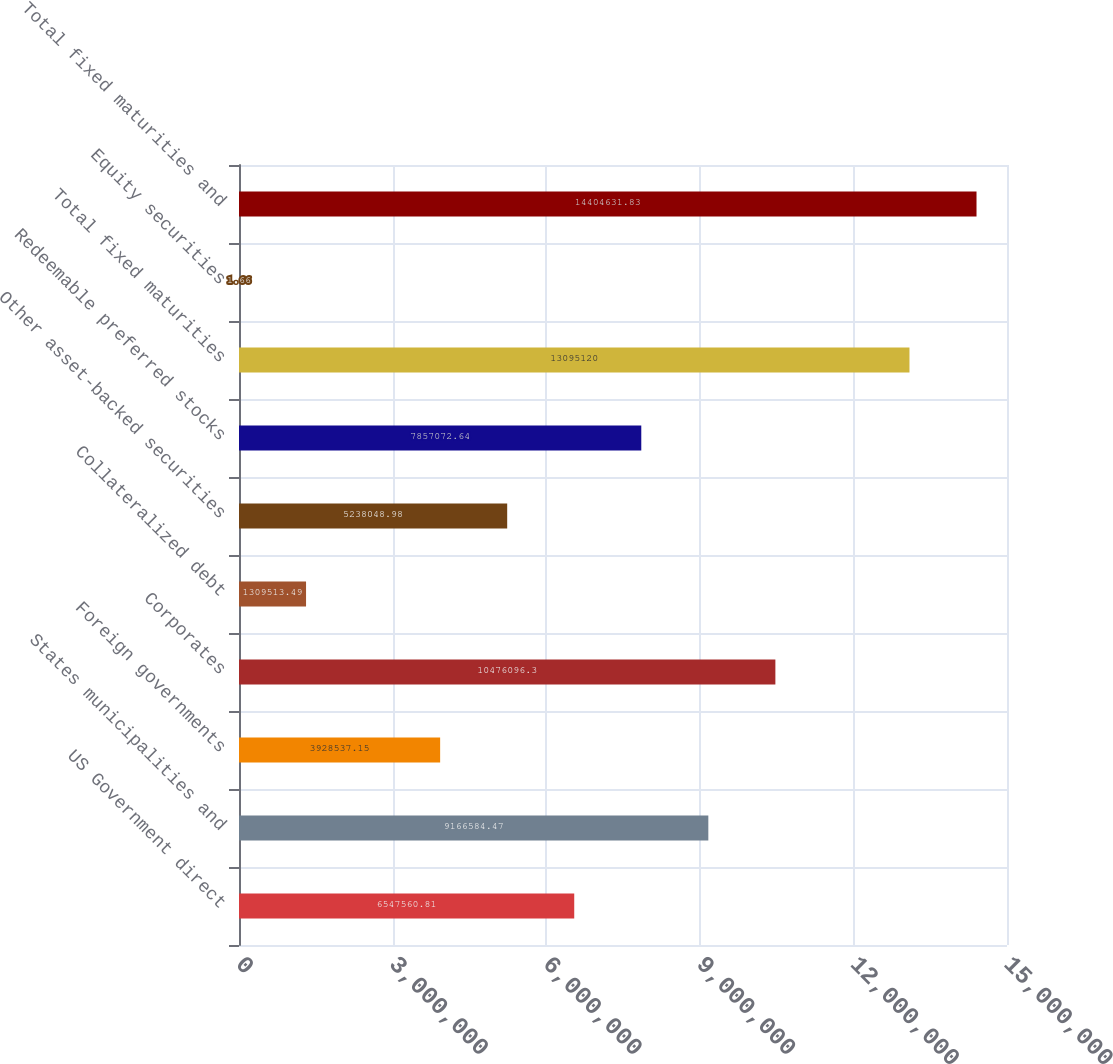Convert chart. <chart><loc_0><loc_0><loc_500><loc_500><bar_chart><fcel>US Government direct<fcel>States municipalities and<fcel>Foreign governments<fcel>Corporates<fcel>Collateralized debt<fcel>Other asset-backed securities<fcel>Redeemable preferred stocks<fcel>Total fixed maturities<fcel>Equity securities<fcel>Total fixed maturities and<nl><fcel>6.54756e+06<fcel>9.16658e+06<fcel>3.92854e+06<fcel>1.04761e+07<fcel>1.30951e+06<fcel>5.23805e+06<fcel>7.85707e+06<fcel>1.30951e+07<fcel>1.66<fcel>1.44046e+07<nl></chart> 